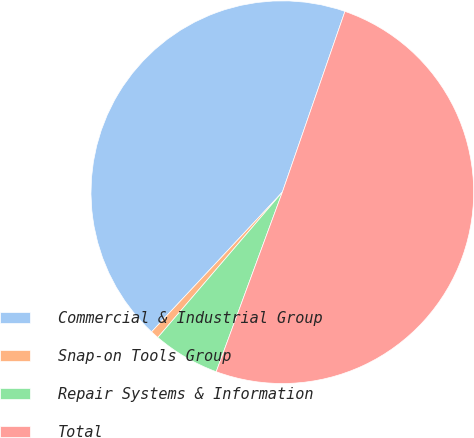Convert chart. <chart><loc_0><loc_0><loc_500><loc_500><pie_chart><fcel>Commercial & Industrial Group<fcel>Snap-on Tools Group<fcel>Repair Systems & Information<fcel>Total<nl><fcel>43.33%<fcel>0.7%<fcel>5.66%<fcel>50.31%<nl></chart> 